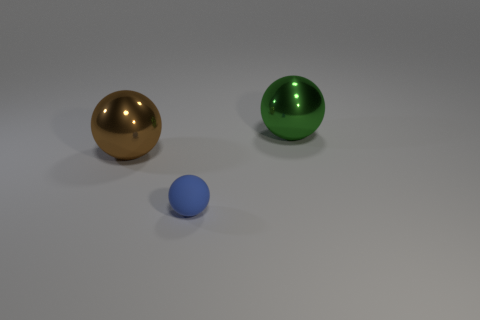Is there any other thing that has the same size as the rubber ball?
Your answer should be compact. No. Is there any other thing that is the same material as the tiny blue thing?
Give a very brief answer. No. What number of large balls have the same color as the small matte sphere?
Your answer should be very brief. 0. Are there any other things that have the same shape as the blue rubber object?
Ensure brevity in your answer.  Yes. What number of cylinders are either metal objects or blue things?
Provide a succinct answer. 0. What is the color of the shiny sphere that is left of the tiny matte thing?
Your answer should be very brief. Brown. There is a green object; how many big green metallic objects are behind it?
Ensure brevity in your answer.  0. What number of things are cyan blocks or metallic balls?
Give a very brief answer. 2. What shape is the thing that is both right of the brown thing and behind the blue thing?
Your answer should be very brief. Sphere. How many big yellow things are there?
Offer a very short reply. 0. 